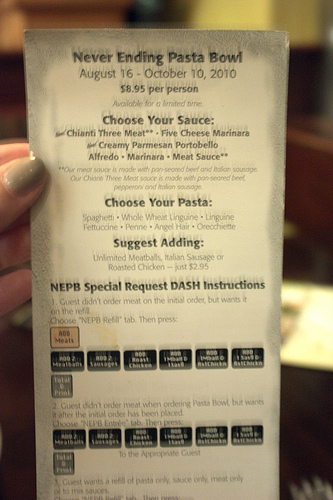<image>
Can you confirm if the nail is on the paper? Yes. Looking at the image, I can see the nail is positioned on top of the paper, with the paper providing support. 